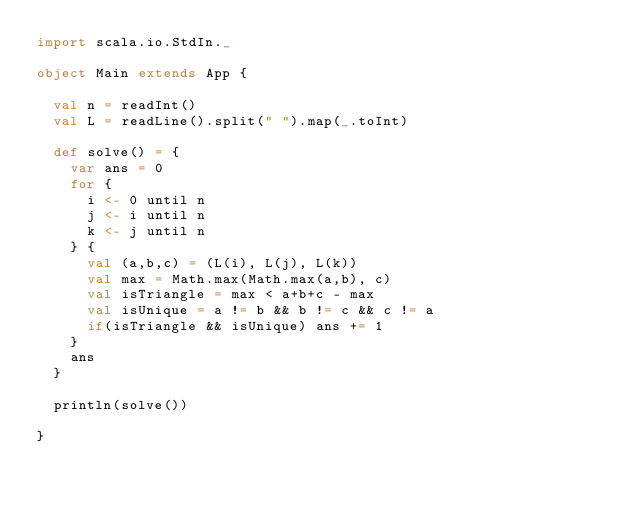Convert code to text. <code><loc_0><loc_0><loc_500><loc_500><_Scala_>import scala.io.StdIn._

object Main extends App {

  val n = readInt()
  val L = readLine().split(" ").map(_.toInt)

  def solve() = {
    var ans = 0
    for {
      i <- 0 until n
      j <- i until n
      k <- j until n
    } {
      val (a,b,c) = (L(i), L(j), L(k))
      val max = Math.max(Math.max(a,b), c)
      val isTriangle = max < a+b+c - max
      val isUnique = a != b && b != c && c != a
      if(isTriangle && isUnique) ans += 1
    }
    ans
  }

  println(solve())

}

</code> 